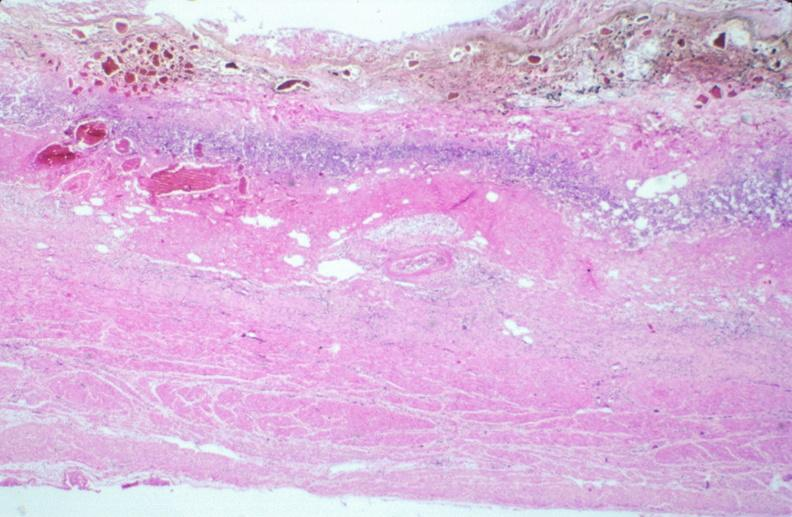what ingested as suicide attempt?
Answer the question using a single word or phrase. Stomach, necrotizing esophagitis and gastritis, sulfuric acid 